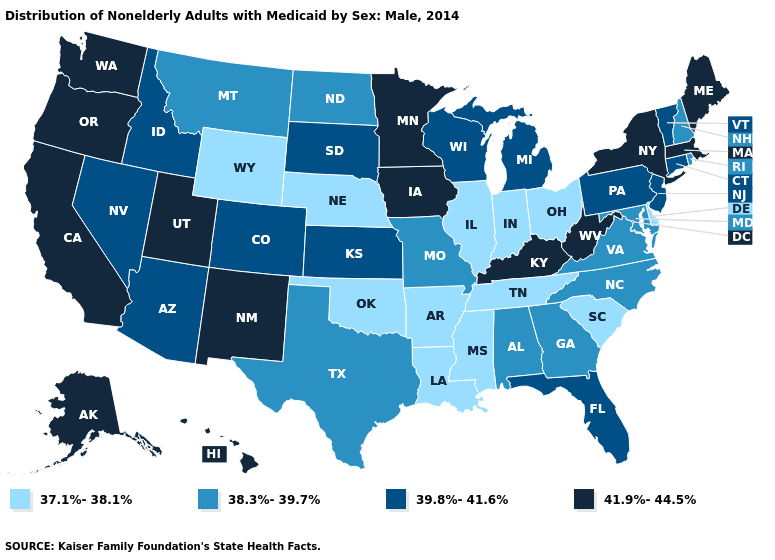Does Alaska have the lowest value in the West?
Give a very brief answer. No. Does New York have the highest value in the Northeast?
Concise answer only. Yes. What is the lowest value in states that border Nebraska?
Write a very short answer. 37.1%-38.1%. What is the value of New York?
Write a very short answer. 41.9%-44.5%. What is the lowest value in the West?
Concise answer only. 37.1%-38.1%. What is the lowest value in states that border New Mexico?
Write a very short answer. 37.1%-38.1%. What is the value of Mississippi?
Short answer required. 37.1%-38.1%. Which states hav the highest value in the MidWest?
Short answer required. Iowa, Minnesota. What is the lowest value in the South?
Be succinct. 37.1%-38.1%. Name the states that have a value in the range 41.9%-44.5%?
Concise answer only. Alaska, California, Hawaii, Iowa, Kentucky, Maine, Massachusetts, Minnesota, New Mexico, New York, Oregon, Utah, Washington, West Virginia. Which states hav the highest value in the West?
Be succinct. Alaska, California, Hawaii, New Mexico, Oregon, Utah, Washington. What is the value of Michigan?
Answer briefly. 39.8%-41.6%. Which states have the lowest value in the USA?
Be succinct. Arkansas, Delaware, Illinois, Indiana, Louisiana, Mississippi, Nebraska, Ohio, Oklahoma, South Carolina, Tennessee, Wyoming. Does Maine have the same value as South Dakota?
Be succinct. No. Name the states that have a value in the range 37.1%-38.1%?
Quick response, please. Arkansas, Delaware, Illinois, Indiana, Louisiana, Mississippi, Nebraska, Ohio, Oklahoma, South Carolina, Tennessee, Wyoming. 